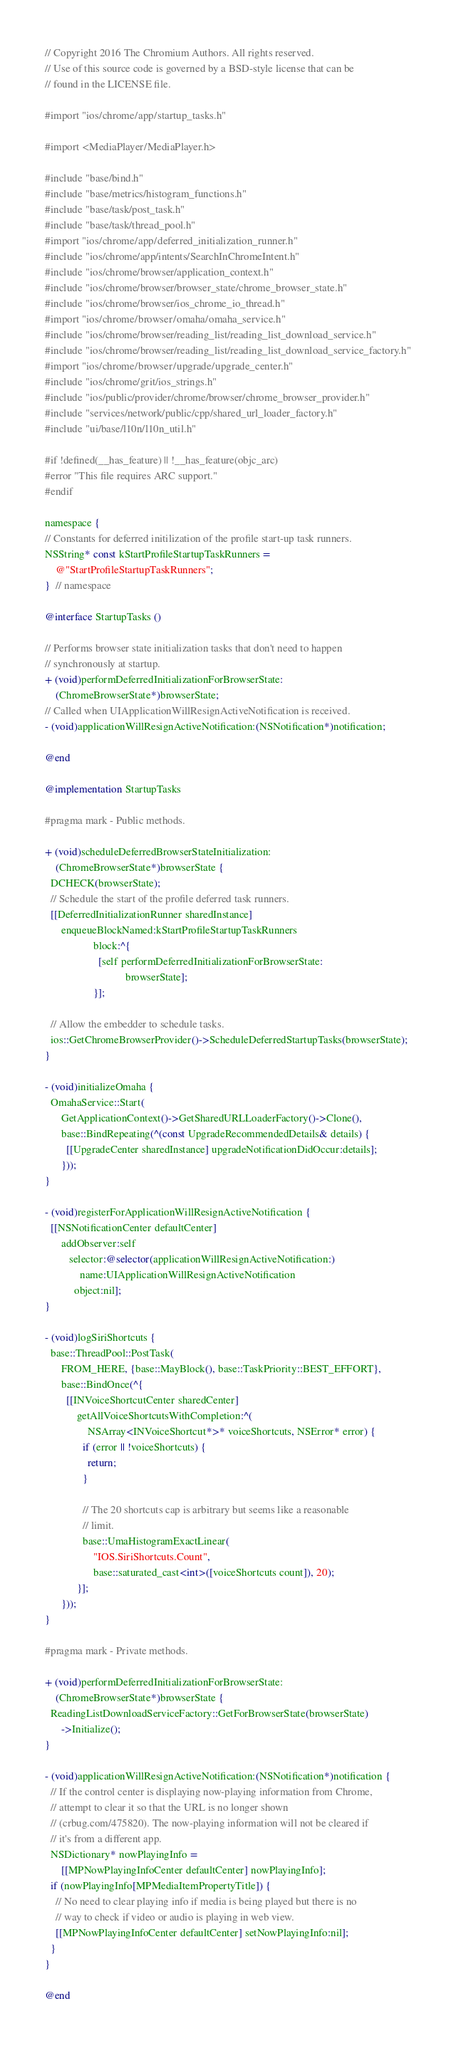Convert code to text. <code><loc_0><loc_0><loc_500><loc_500><_ObjectiveC_>// Copyright 2016 The Chromium Authors. All rights reserved.
// Use of this source code is governed by a BSD-style license that can be
// found in the LICENSE file.

#import "ios/chrome/app/startup_tasks.h"

#import <MediaPlayer/MediaPlayer.h>

#include "base/bind.h"
#include "base/metrics/histogram_functions.h"
#include "base/task/post_task.h"
#include "base/task/thread_pool.h"
#import "ios/chrome/app/deferred_initialization_runner.h"
#include "ios/chrome/app/intents/SearchInChromeIntent.h"
#include "ios/chrome/browser/application_context.h"
#include "ios/chrome/browser/browser_state/chrome_browser_state.h"
#include "ios/chrome/browser/ios_chrome_io_thread.h"
#import "ios/chrome/browser/omaha/omaha_service.h"
#include "ios/chrome/browser/reading_list/reading_list_download_service.h"
#include "ios/chrome/browser/reading_list/reading_list_download_service_factory.h"
#import "ios/chrome/browser/upgrade/upgrade_center.h"
#include "ios/chrome/grit/ios_strings.h"
#include "ios/public/provider/chrome/browser/chrome_browser_provider.h"
#include "services/network/public/cpp/shared_url_loader_factory.h"
#include "ui/base/l10n/l10n_util.h"

#if !defined(__has_feature) || !__has_feature(objc_arc)
#error "This file requires ARC support."
#endif

namespace {
// Constants for deferred initilization of the profile start-up task runners.
NSString* const kStartProfileStartupTaskRunners =
    @"StartProfileStartupTaskRunners";
}  // namespace

@interface StartupTasks ()

// Performs browser state initialization tasks that don't need to happen
// synchronously at startup.
+ (void)performDeferredInitializationForBrowserState:
    (ChromeBrowserState*)browserState;
// Called when UIApplicationWillResignActiveNotification is received.
- (void)applicationWillResignActiveNotification:(NSNotification*)notification;

@end

@implementation StartupTasks

#pragma mark - Public methods.

+ (void)scheduleDeferredBrowserStateInitialization:
    (ChromeBrowserState*)browserState {
  DCHECK(browserState);
  // Schedule the start of the profile deferred task runners.
  [[DeferredInitializationRunner sharedInstance]
      enqueueBlockNamed:kStartProfileStartupTaskRunners
                  block:^{
                    [self performDeferredInitializationForBrowserState:
                              browserState];
                  }];

  // Allow the embedder to schedule tasks.
  ios::GetChromeBrowserProvider()->ScheduleDeferredStartupTasks(browserState);
}

- (void)initializeOmaha {
  OmahaService::Start(
      GetApplicationContext()->GetSharedURLLoaderFactory()->Clone(),
      base::BindRepeating(^(const UpgradeRecommendedDetails& details) {
        [[UpgradeCenter sharedInstance] upgradeNotificationDidOccur:details];
      }));
}

- (void)registerForApplicationWillResignActiveNotification {
  [[NSNotificationCenter defaultCenter]
      addObserver:self
         selector:@selector(applicationWillResignActiveNotification:)
             name:UIApplicationWillResignActiveNotification
           object:nil];
}

- (void)logSiriShortcuts {
  base::ThreadPool::PostTask(
      FROM_HERE, {base::MayBlock(), base::TaskPriority::BEST_EFFORT},
      base::BindOnce(^{
        [[INVoiceShortcutCenter sharedCenter]
            getAllVoiceShortcutsWithCompletion:^(
                NSArray<INVoiceShortcut*>* voiceShortcuts, NSError* error) {
              if (error || !voiceShortcuts) {
                return;
              }

              // The 20 shortcuts cap is arbitrary but seems like a reasonable
              // limit.
              base::UmaHistogramExactLinear(
                  "IOS.SiriShortcuts.Count",
                  base::saturated_cast<int>([voiceShortcuts count]), 20);
            }];
      }));
}

#pragma mark - Private methods.

+ (void)performDeferredInitializationForBrowserState:
    (ChromeBrowserState*)browserState {
  ReadingListDownloadServiceFactory::GetForBrowserState(browserState)
      ->Initialize();
}

- (void)applicationWillResignActiveNotification:(NSNotification*)notification {
  // If the control center is displaying now-playing information from Chrome,
  // attempt to clear it so that the URL is no longer shown
  // (crbug.com/475820). The now-playing information will not be cleared if
  // it's from a different app.
  NSDictionary* nowPlayingInfo =
      [[MPNowPlayingInfoCenter defaultCenter] nowPlayingInfo];
  if (nowPlayingInfo[MPMediaItemPropertyTitle]) {
    // No need to clear playing info if media is being played but there is no
    // way to check if video or audio is playing in web view.
    [[MPNowPlayingInfoCenter defaultCenter] setNowPlayingInfo:nil];
  }
}

@end
</code> 